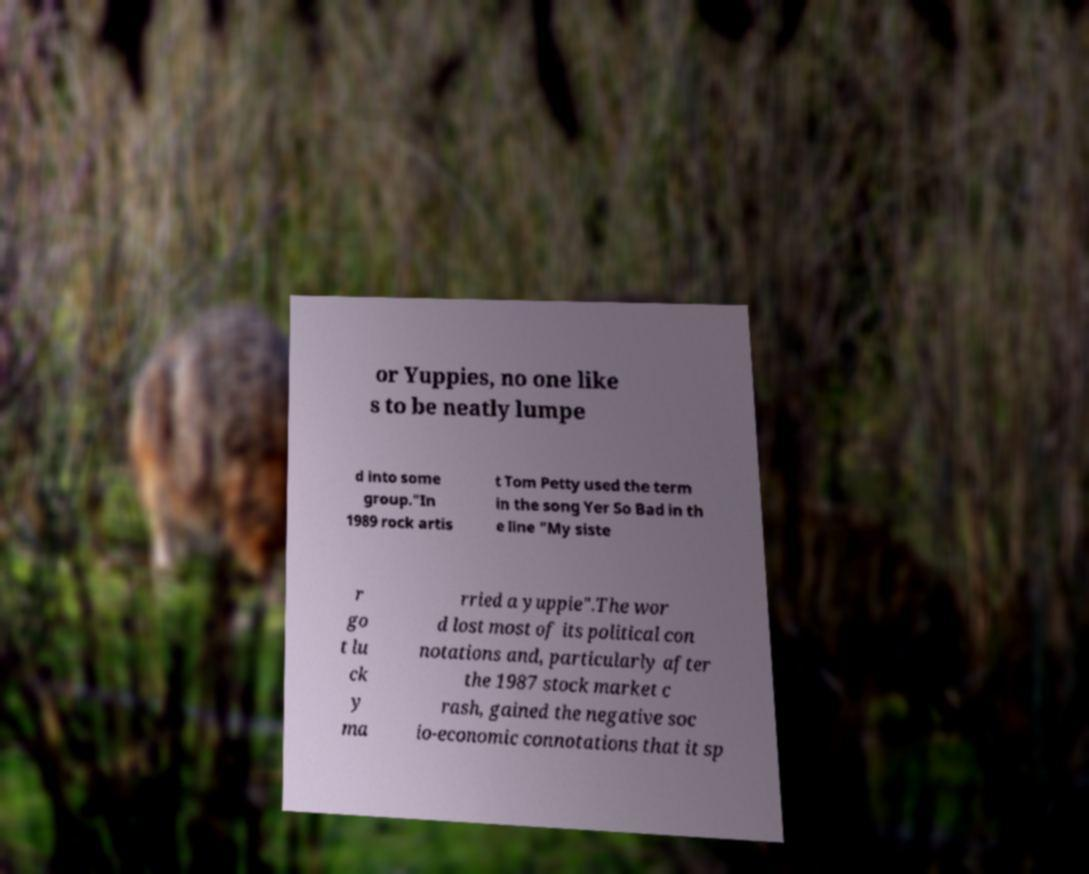I need the written content from this picture converted into text. Can you do that? or Yuppies, no one like s to be neatly lumpe d into some group."In 1989 rock artis t Tom Petty used the term in the song Yer So Bad in th e line "My siste r go t lu ck y ma rried a yuppie".The wor d lost most of its political con notations and, particularly after the 1987 stock market c rash, gained the negative soc io-economic connotations that it sp 